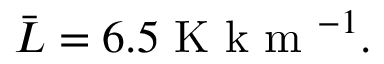Convert formula to latex. <formula><loc_0><loc_0><loc_500><loc_500>\bar { L } = 6 . 5 K k m ^ { - 1 } .</formula> 